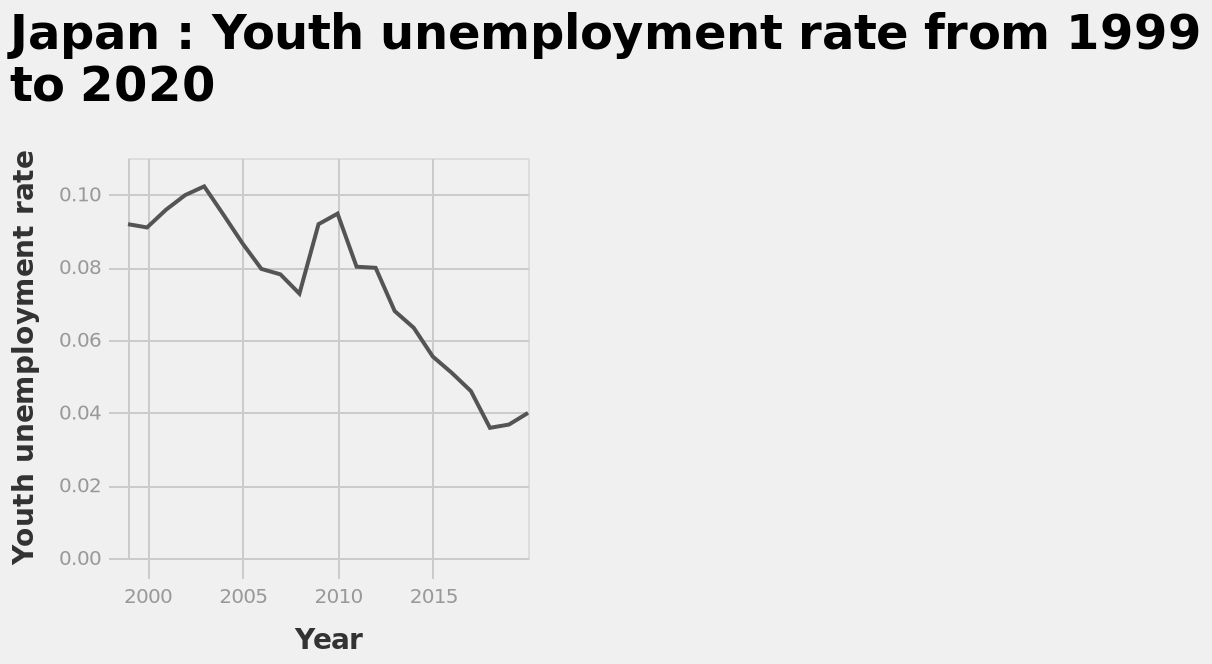<image>
What does the x-axis represent on the graph?  The x-axis represents the years from 1999 to 2020. When did employment begin to increase?  Employment began to increase in 2000. 